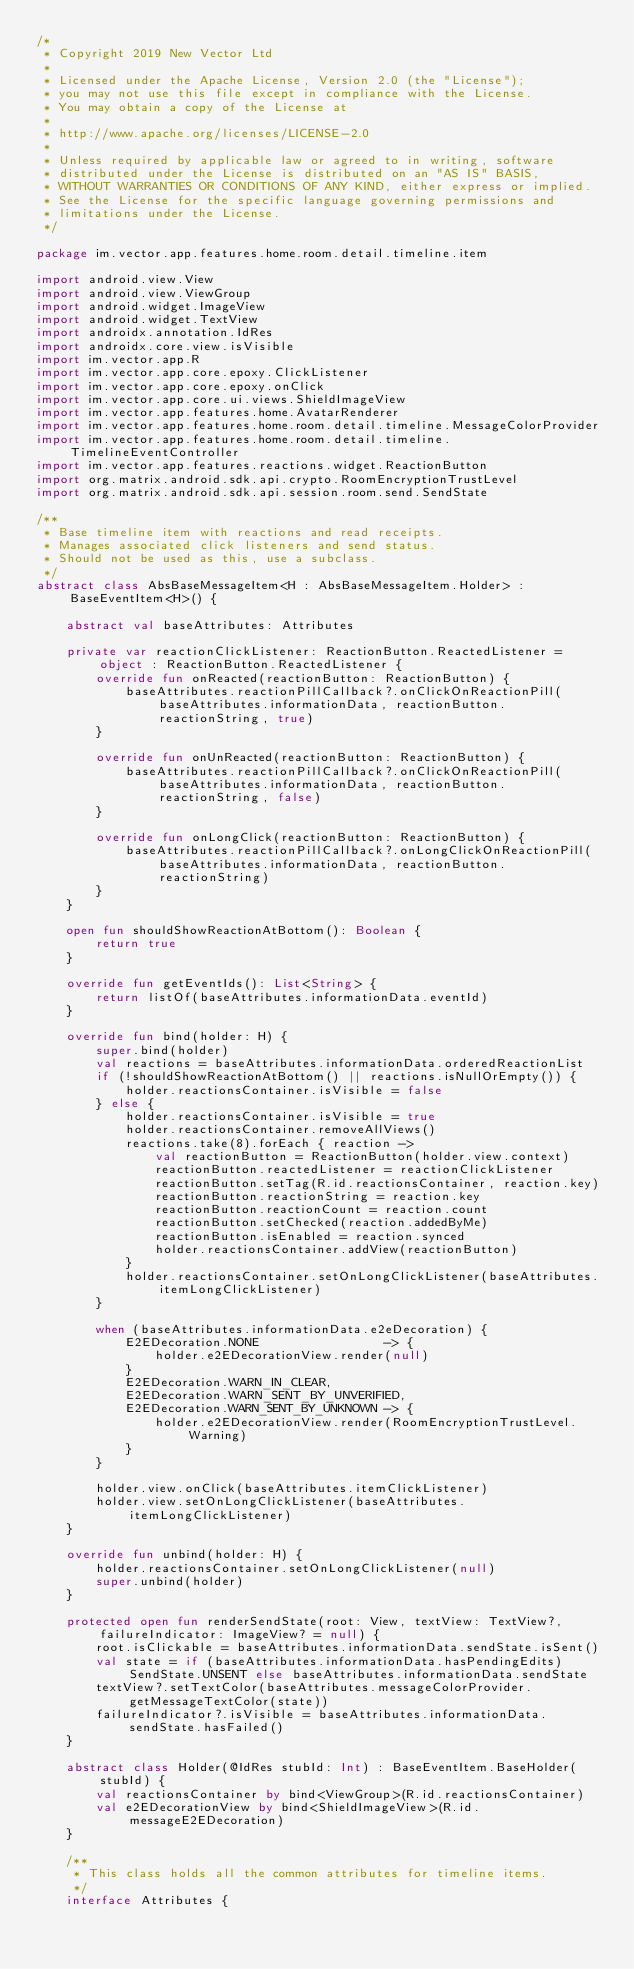<code> <loc_0><loc_0><loc_500><loc_500><_Kotlin_>/*
 * Copyright 2019 New Vector Ltd
 *
 * Licensed under the Apache License, Version 2.0 (the "License");
 * you may not use this file except in compliance with the License.
 * You may obtain a copy of the License at
 *
 * http://www.apache.org/licenses/LICENSE-2.0
 *
 * Unless required by applicable law or agreed to in writing, software
 * distributed under the License is distributed on an "AS IS" BASIS,
 * WITHOUT WARRANTIES OR CONDITIONS OF ANY KIND, either express or implied.
 * See the License for the specific language governing permissions and
 * limitations under the License.
 */

package im.vector.app.features.home.room.detail.timeline.item

import android.view.View
import android.view.ViewGroup
import android.widget.ImageView
import android.widget.TextView
import androidx.annotation.IdRes
import androidx.core.view.isVisible
import im.vector.app.R
import im.vector.app.core.epoxy.ClickListener
import im.vector.app.core.epoxy.onClick
import im.vector.app.core.ui.views.ShieldImageView
import im.vector.app.features.home.AvatarRenderer
import im.vector.app.features.home.room.detail.timeline.MessageColorProvider
import im.vector.app.features.home.room.detail.timeline.TimelineEventController
import im.vector.app.features.reactions.widget.ReactionButton
import org.matrix.android.sdk.api.crypto.RoomEncryptionTrustLevel
import org.matrix.android.sdk.api.session.room.send.SendState

/**
 * Base timeline item with reactions and read receipts.
 * Manages associated click listeners and send status.
 * Should not be used as this, use a subclass.
 */
abstract class AbsBaseMessageItem<H : AbsBaseMessageItem.Holder> : BaseEventItem<H>() {

    abstract val baseAttributes: Attributes

    private var reactionClickListener: ReactionButton.ReactedListener = object : ReactionButton.ReactedListener {
        override fun onReacted(reactionButton: ReactionButton) {
            baseAttributes.reactionPillCallback?.onClickOnReactionPill(baseAttributes.informationData, reactionButton.reactionString, true)
        }

        override fun onUnReacted(reactionButton: ReactionButton) {
            baseAttributes.reactionPillCallback?.onClickOnReactionPill(baseAttributes.informationData, reactionButton.reactionString, false)
        }

        override fun onLongClick(reactionButton: ReactionButton) {
            baseAttributes.reactionPillCallback?.onLongClickOnReactionPill(baseAttributes.informationData, reactionButton.reactionString)
        }
    }

    open fun shouldShowReactionAtBottom(): Boolean {
        return true
    }

    override fun getEventIds(): List<String> {
        return listOf(baseAttributes.informationData.eventId)
    }

    override fun bind(holder: H) {
        super.bind(holder)
        val reactions = baseAttributes.informationData.orderedReactionList
        if (!shouldShowReactionAtBottom() || reactions.isNullOrEmpty()) {
            holder.reactionsContainer.isVisible = false
        } else {
            holder.reactionsContainer.isVisible = true
            holder.reactionsContainer.removeAllViews()
            reactions.take(8).forEach { reaction ->
                val reactionButton = ReactionButton(holder.view.context)
                reactionButton.reactedListener = reactionClickListener
                reactionButton.setTag(R.id.reactionsContainer, reaction.key)
                reactionButton.reactionString = reaction.key
                reactionButton.reactionCount = reaction.count
                reactionButton.setChecked(reaction.addedByMe)
                reactionButton.isEnabled = reaction.synced
                holder.reactionsContainer.addView(reactionButton)
            }
            holder.reactionsContainer.setOnLongClickListener(baseAttributes.itemLongClickListener)
        }

        when (baseAttributes.informationData.e2eDecoration) {
            E2EDecoration.NONE                 -> {
                holder.e2EDecorationView.render(null)
            }
            E2EDecoration.WARN_IN_CLEAR,
            E2EDecoration.WARN_SENT_BY_UNVERIFIED,
            E2EDecoration.WARN_SENT_BY_UNKNOWN -> {
                holder.e2EDecorationView.render(RoomEncryptionTrustLevel.Warning)
            }
        }

        holder.view.onClick(baseAttributes.itemClickListener)
        holder.view.setOnLongClickListener(baseAttributes.itemLongClickListener)
    }

    override fun unbind(holder: H) {
        holder.reactionsContainer.setOnLongClickListener(null)
        super.unbind(holder)
    }

    protected open fun renderSendState(root: View, textView: TextView?, failureIndicator: ImageView? = null) {
        root.isClickable = baseAttributes.informationData.sendState.isSent()
        val state = if (baseAttributes.informationData.hasPendingEdits) SendState.UNSENT else baseAttributes.informationData.sendState
        textView?.setTextColor(baseAttributes.messageColorProvider.getMessageTextColor(state))
        failureIndicator?.isVisible = baseAttributes.informationData.sendState.hasFailed()
    }

    abstract class Holder(@IdRes stubId: Int) : BaseEventItem.BaseHolder(stubId) {
        val reactionsContainer by bind<ViewGroup>(R.id.reactionsContainer)
        val e2EDecorationView by bind<ShieldImageView>(R.id.messageE2EDecoration)
    }

    /**
     * This class holds all the common attributes for timeline items.
     */
    interface Attributes {</code> 